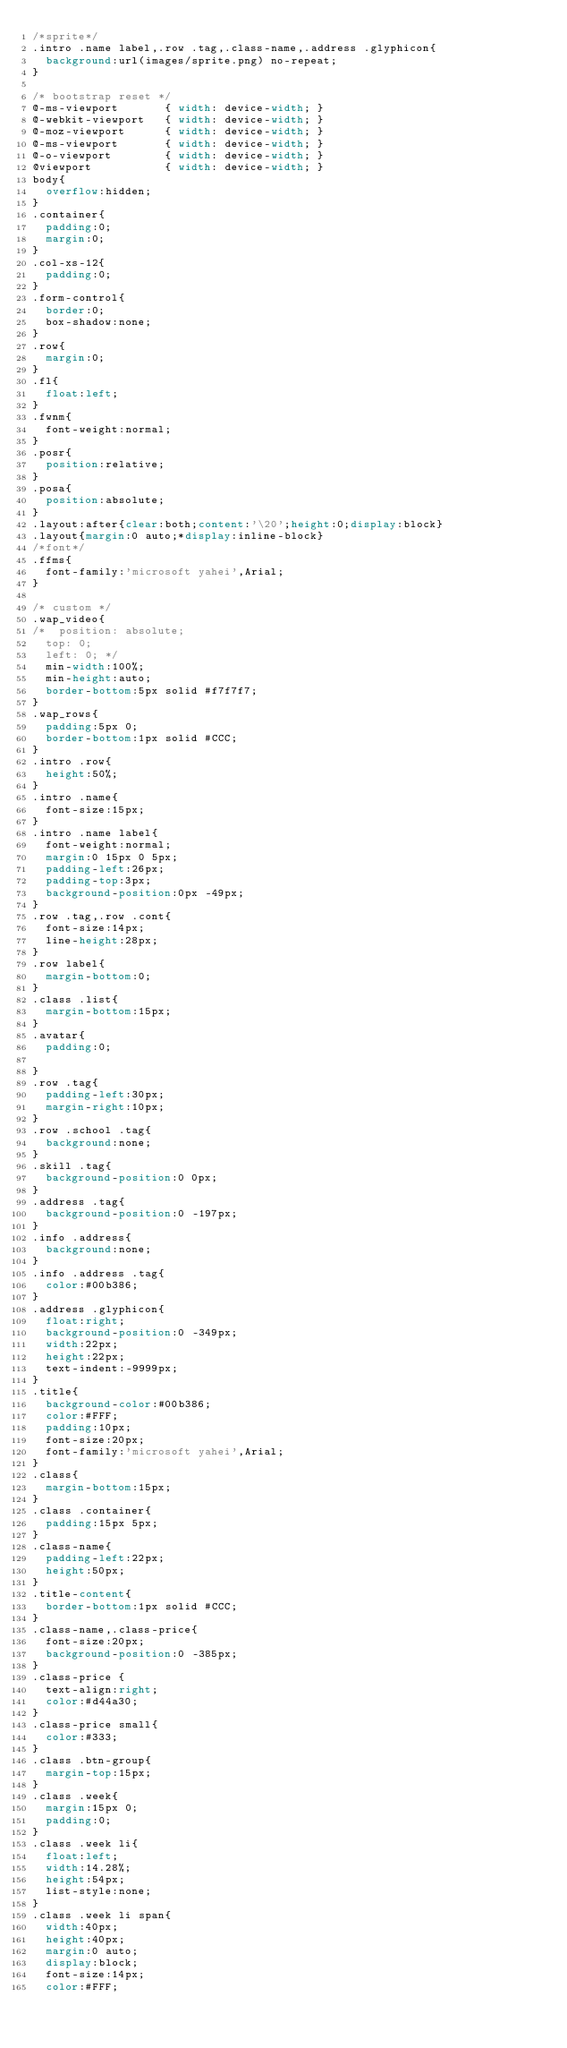Convert code to text. <code><loc_0><loc_0><loc_500><loc_500><_CSS_>/*sprite*/
.intro .name label,.row .tag,.class-name,.address .glyphicon{
	background:url(images/sprite.png) no-repeat;
}

/* bootstrap reset */
@-ms-viewport       { width: device-width; }
@-webkit-viewport   { width: device-width; }
@-moz-viewport      { width: device-width; }
@-ms-viewport       { width: device-width; }
@-o-viewport        { width: device-width; }
@viewport           { width: device-width; }
body{
	overflow:hidden;
}
.container{
	padding:0;
	margin:0;
}
.col-xs-12{
	padding:0;
}
.form-control{
	border:0;
	box-shadow:none;
}
.row{
	margin:0;
}
.fl{
	float:left;
}
.fwnm{
	font-weight:normal;
}
.posr{
	position:relative;
}
.posa{
	position:absolute;
}
.layout:after{clear:both;content:'\20';height:0;display:block}
.layout{margin:0 auto;*display:inline-block}
/*font*/
.ffms{
	font-family:'microsoft yahei',Arial;
}

/* custom */
.wap_video{
/* 	position: absolute;
	top: 0;
	left: 0; */
	min-width:100%;
	min-height:auto;
	border-bottom:5px solid #f7f7f7;
}
.wap_rows{
	padding:5px 0;
	border-bottom:1px solid #CCC;
}
.intro .row{
	height:50%;
}
.intro .name{
	font-size:15px;
}
.intro .name label{
	font-weight:normal;
	margin:0 15px 0 5px;
	padding-left:26px;
	padding-top:3px;
	background-position:0px -49px;
}
.row .tag,.row .cont{
	font-size:14px;
	line-height:28px;
}
.row label{
	margin-bottom:0;
}
.class .list{
	margin-bottom:15px;
}
.avatar{
	padding:0;

}
.row .tag{
	padding-left:30px;
	margin-right:10px;
}
.row .school .tag{
	background:none;
}
.skill .tag{
	background-position:0 0px;
}
.address .tag{
	background-position:0 -197px;
}
.info .address{
	background:none;
}
.info .address .tag{
	color:#00b386;
}
.address .glyphicon{
	float:right;
	background-position:0 -349px;
	width:22px;
	height:22px;
	text-indent:-9999px;
}
.title{
	background-color:#00b386;
	color:#FFF;
	padding:10px;
	font-size:20px;
	font-family:'microsoft yahei',Arial;
}
.class{
	margin-bottom:15px;
}
.class .container{
	padding:15px 5px;
}
.class-name{
	padding-left:22px;
	height:50px;
}
.title-content{
	border-bottom:1px solid #CCC;
}
.class-name,.class-price{
	font-size:20px;
	background-position:0 -385px;
}
.class-price {
	text-align:right;
	color:#d44a30;
}
.class-price small{
	color:#333;
}
.class .btn-group{
	margin-top:15px;
}
.class .week{
	margin:15px 0;
	padding:0;
}
.class .week li{
	float:left;
	width:14.28%;
	height:54px;
	list-style:none;
}
.class .week li span{
	width:40px;
	height:40px;
	margin:0 auto;
	display:block;
	font-size:14px;
	color:#FFF;</code> 